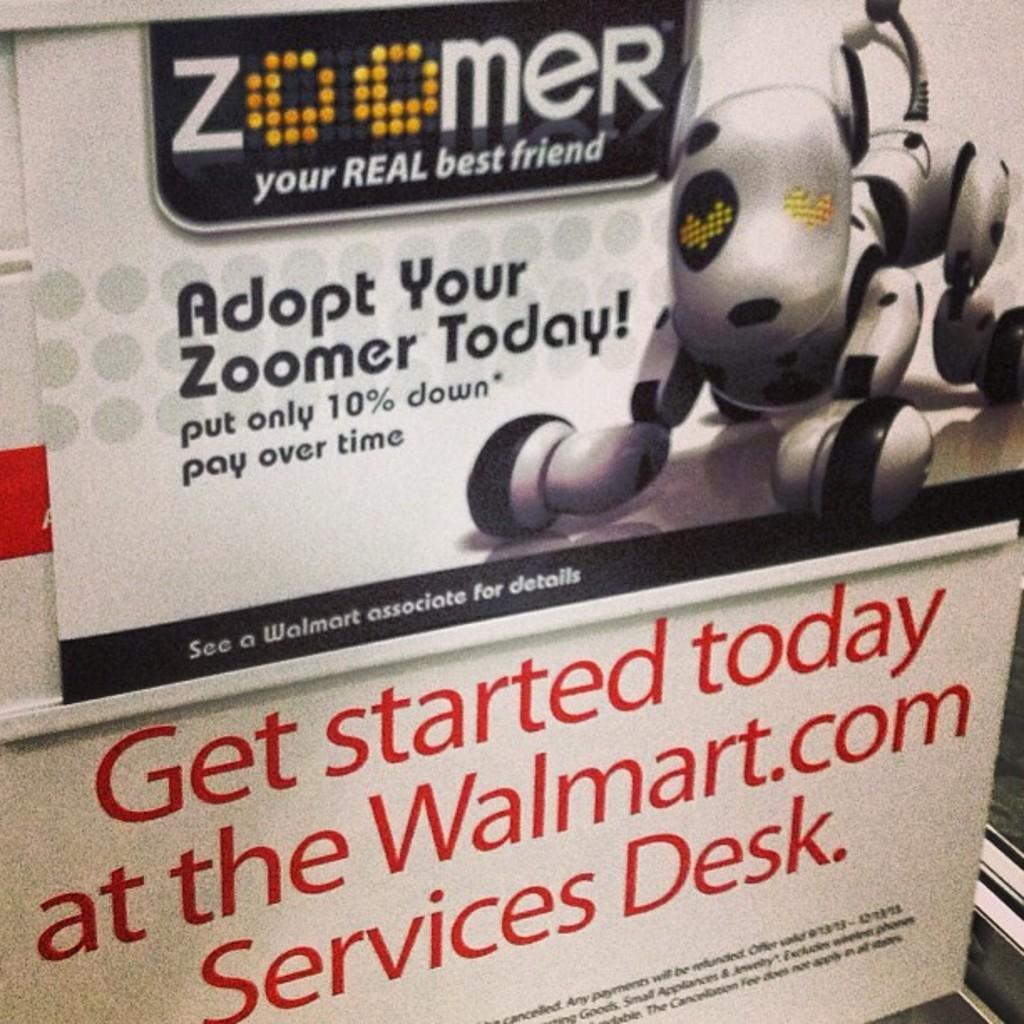<image>
Render a clear and concise summary of the photo. A cute Robot dog is featured on this poster for Zoomer at Walmart 